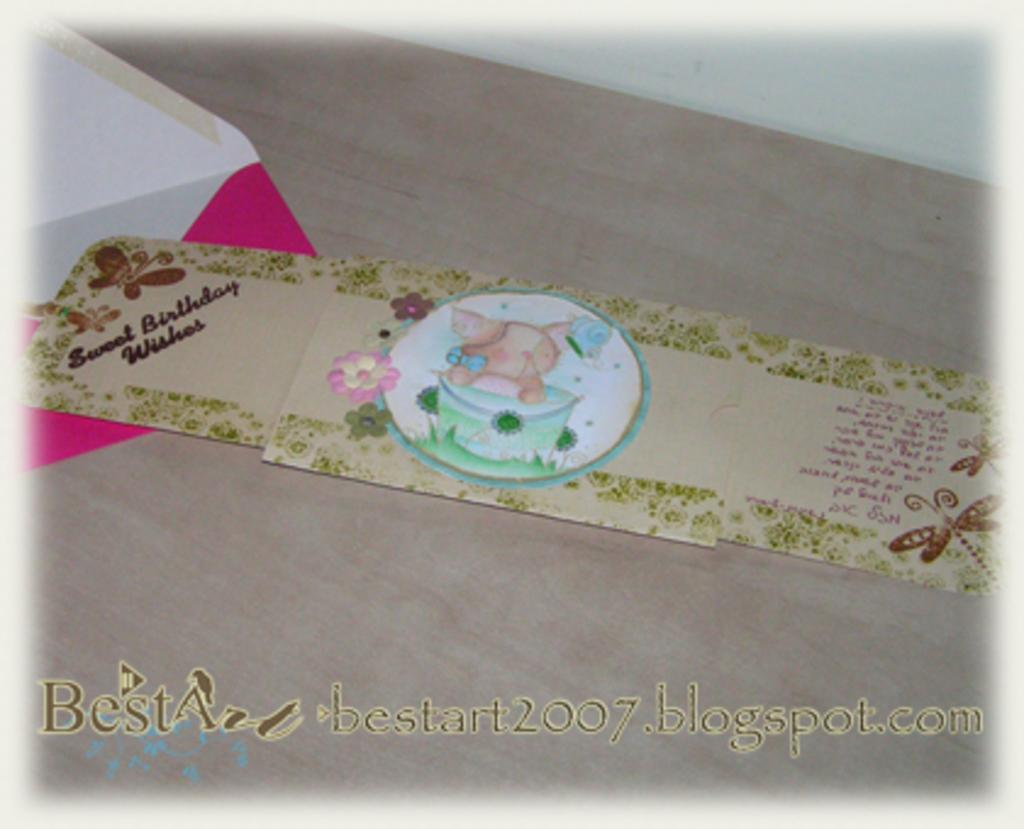What year does the url say?
Your response must be concise. 2007. What occasion is this for?
Your answer should be compact. Birthday. 